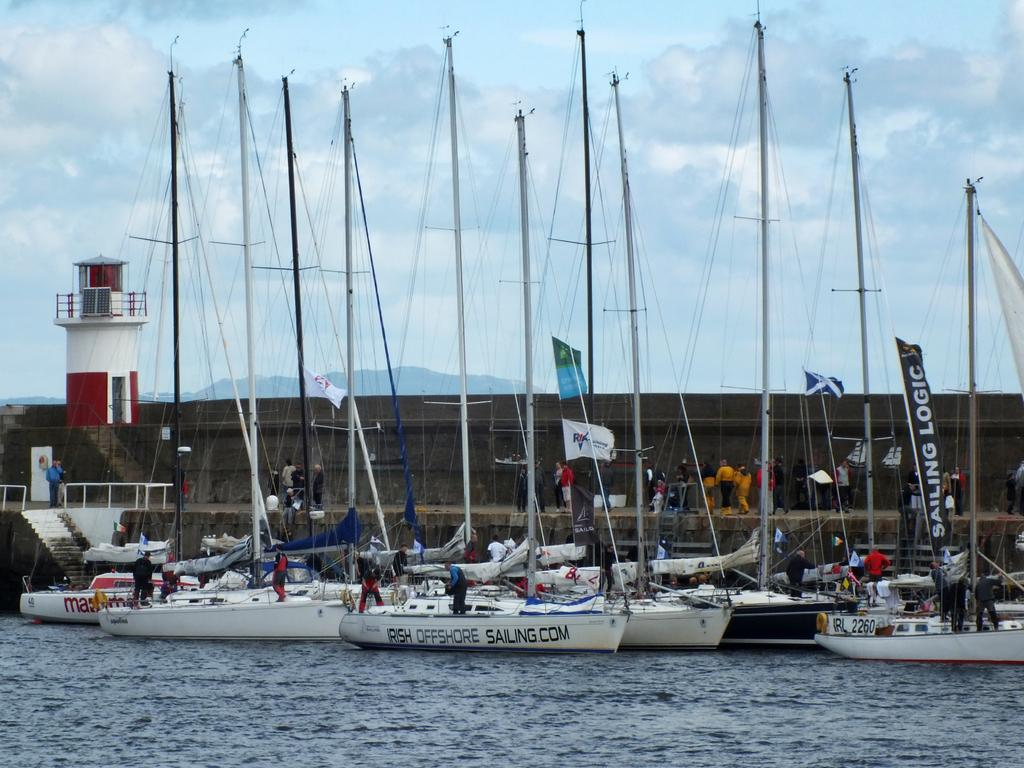<image>
Relay a brief, clear account of the picture shown. one of the many sailboats docked together are called irish offshore sailing 